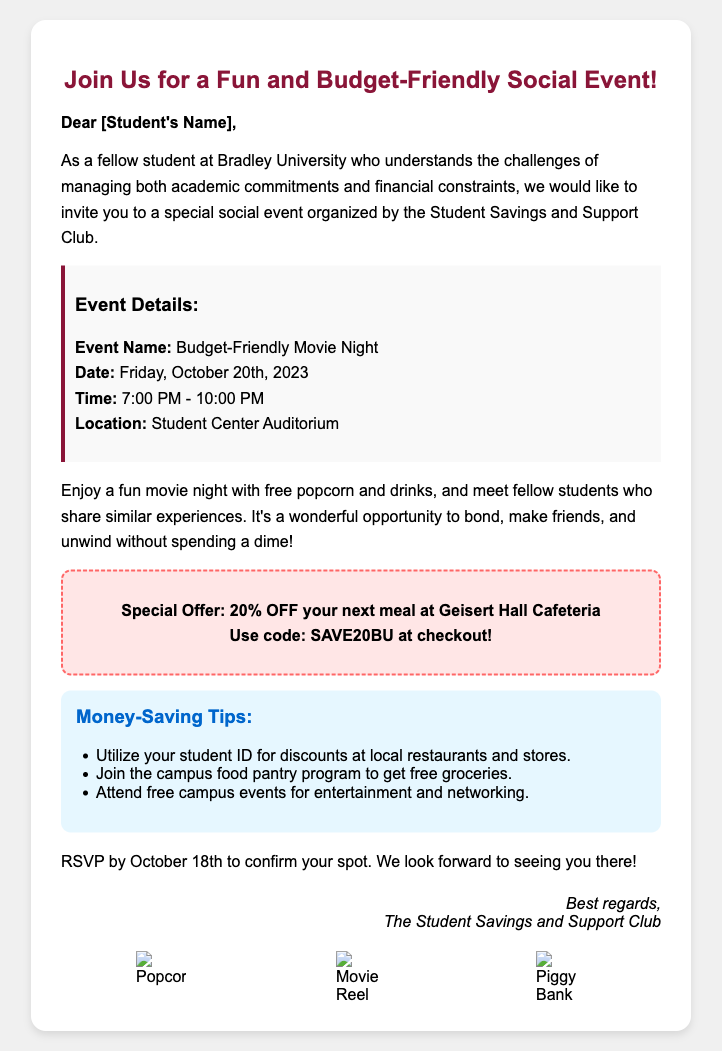What is the event name? The document specifies the name of the event as "Budget-Friendly Movie Night."
Answer: Budget-Friendly Movie Night What is the date of the event? According to the document, the event is scheduled for "Friday, October 20th, 2023."
Answer: Friday, October 20th, 2023 What time does the event start? The starting time of the event is given in the document as "7:00 PM."
Answer: 7:00 PM What special offer is mentioned? The document lists a special offer of "20% OFF your next meal at Geisert Hall Cafeteria."
Answer: 20% OFF your next meal at Geisert Hall Cafeteria What is the RSVP deadline? The RSVP deadline is stated as "October 18th" in the document.
Answer: October 18th What is one tip for saving money at local restaurants? The document suggests using "your student ID for discounts at local restaurants and stores."
Answer: your student ID for discounts How can students get free groceries? The document mentions joining "the campus food pantry program" to get free groceries.
Answer: the campus food pantry program What kind of snacks are provided at the event? The document states that there will be "free popcorn and drinks" at the event.
Answer: free popcorn and drinks Who organized the event? The document indicates that the event is organized by "The Student Savings and Support Club."
Answer: The Student Savings and Support Club What visual elements are included in the greeting card? The document mentions "cheerful graphics" and includes icons like "popcorn," "movie reel," and "piggy bank."
Answer: popcorn, movie reel, piggy bank 